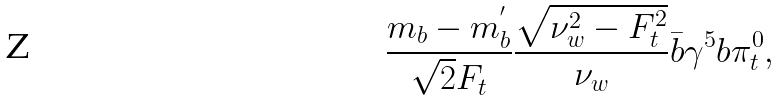Convert formula to latex. <formula><loc_0><loc_0><loc_500><loc_500>\frac { m _ { b } - m _ { b } ^ { ^ { \prime } } } { \sqrt { 2 } F _ { t } } \frac { \sqrt { \nu _ { w } ^ { 2 } - F _ { t } ^ { 2 } } } { \nu _ { w } } \bar { b } \gamma ^ { 5 } b \pi _ { t } ^ { 0 } ,</formula> 